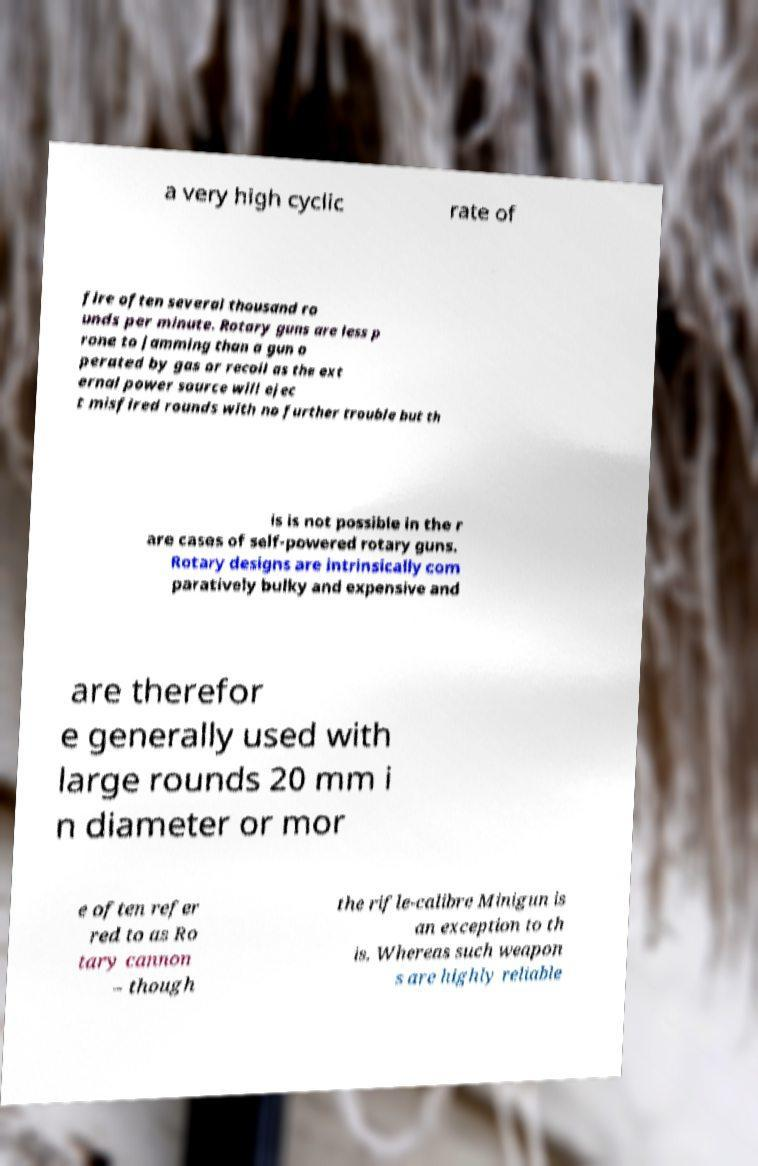Please identify and transcribe the text found in this image. a very high cyclic rate of fire often several thousand ro unds per minute. Rotary guns are less p rone to jamming than a gun o perated by gas or recoil as the ext ernal power source will ejec t misfired rounds with no further trouble but th is is not possible in the r are cases of self-powered rotary guns. Rotary designs are intrinsically com paratively bulky and expensive and are therefor e generally used with large rounds 20 mm i n diameter or mor e often refer red to as Ro tary cannon – though the rifle-calibre Minigun is an exception to th is. Whereas such weapon s are highly reliable 